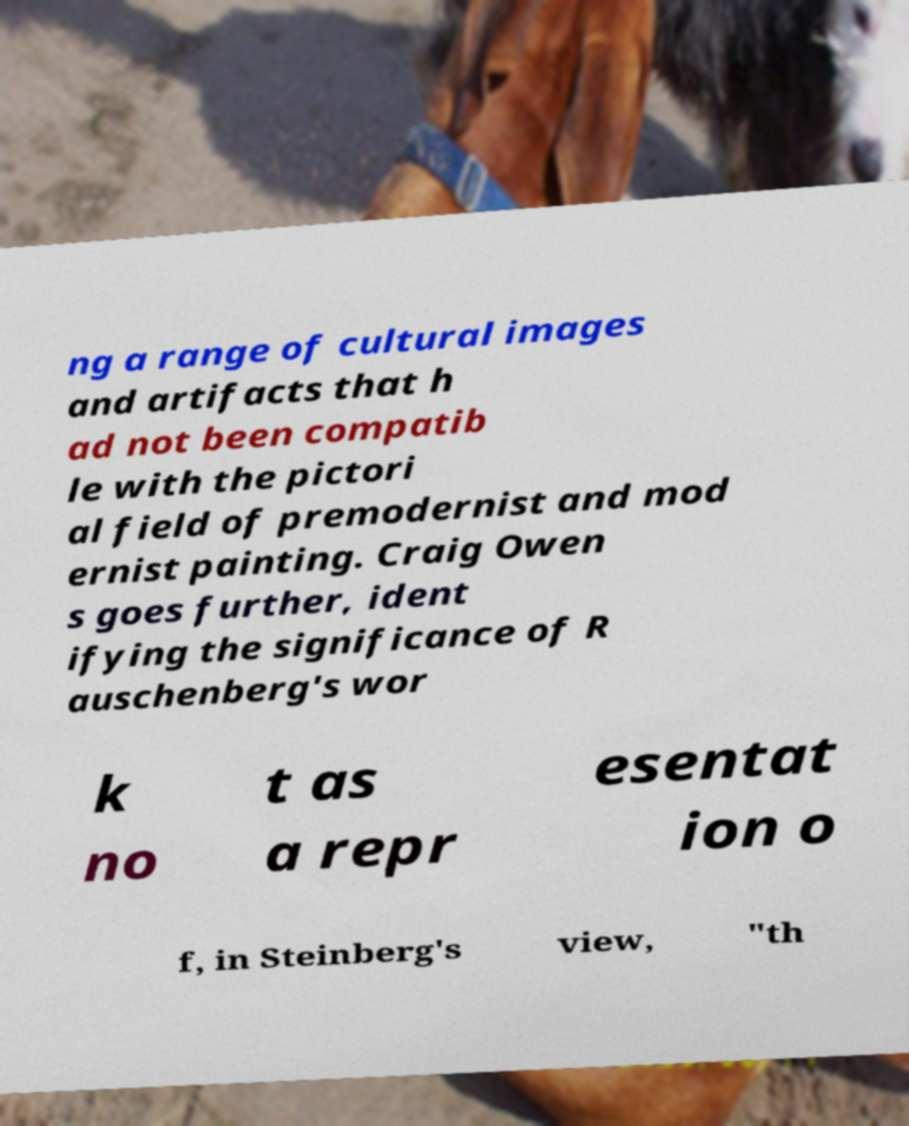What messages or text are displayed in this image? I need them in a readable, typed format. ng a range of cultural images and artifacts that h ad not been compatib le with the pictori al field of premodernist and mod ernist painting. Craig Owen s goes further, ident ifying the significance of R auschenberg's wor k no t as a repr esentat ion o f, in Steinberg's view, "th 